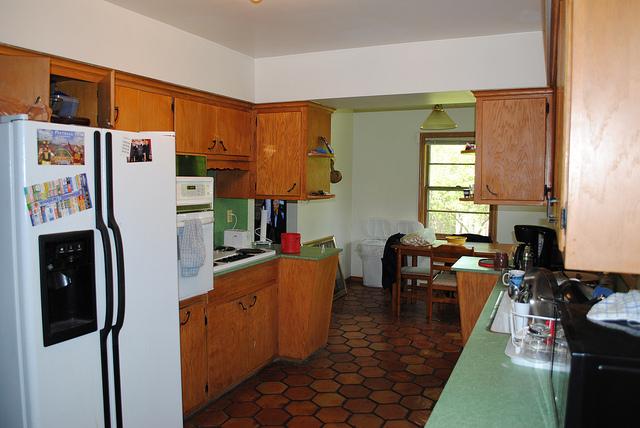Does the refrigerator have an ice dispenser on the door?
Give a very brief answer. Yes. How many doors are on the fridge?
Be succinct. 2. What color is the wall?
Concise answer only. White. Does the dining area have the same style floor as the rest of the kitchen?
Short answer required. Yes. 